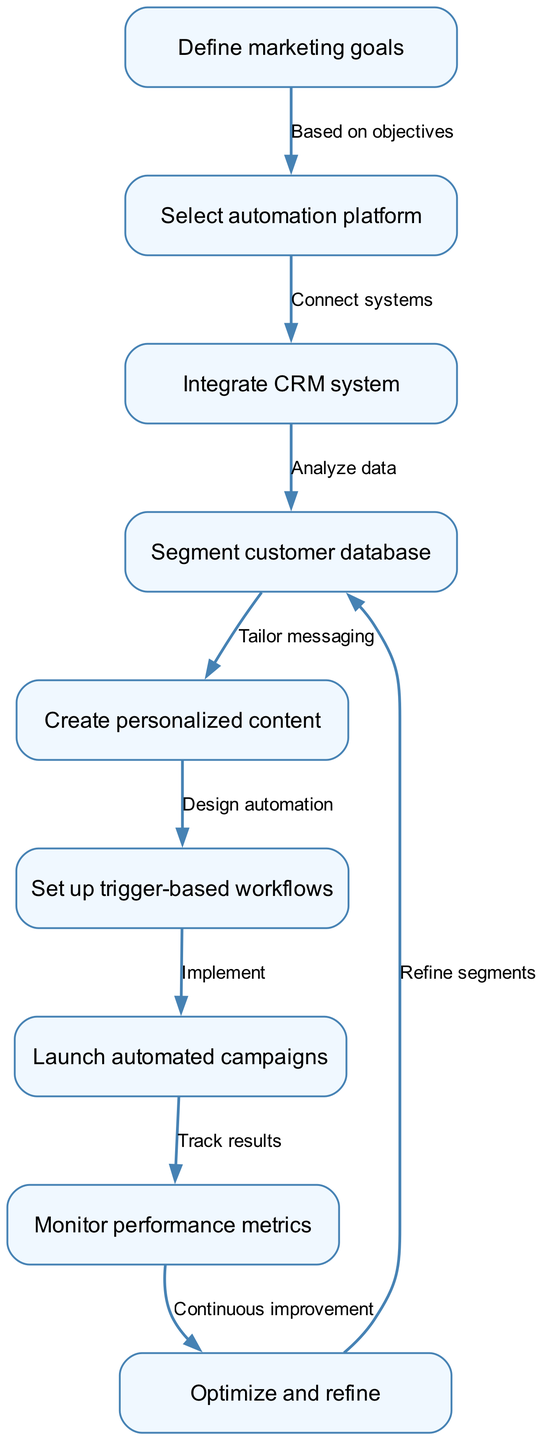What is the first step in the flow chart? The first step in the flow chart, based on the nodes, is "Define marketing goals." This is indicated as the starting point before any other actions can take place.
Answer: Define marketing goals How many steps are there in total? The total number of nodes or steps in the flow chart is nine. Counting each node listed, we have nine distinct actions to follow.
Answer: 9 What follows "Select automation platform"? After "Select automation platform," the next step is "Integrate CRM system." The diagram specifies this directional flow clearly between these two actions.
Answer: Integrate CRM system What type of content is created after segmenting the customer database? The content created after segmenting the customer database is "Create personalized content." The flow indicates that personalized content creation is dependent on customer segmentation.
Answer: Create personalized content How does the flow lead back to "Segment customer database"? After "Optimize and refine," the flow chart indicates a return to "Segment customer database." This shows that refining optimizations leads to a reevaluation of customer segments for continuous improvement.
Answer: Refine segments What action is taken after launching automated campaigns? After launching automated campaigns, the next action is "Monitor performance metrics." The direct flow from one action to the next emphasizes the importance of tracking effectiveness after launching campaigns.
Answer: Monitor performance metrics What is the relationship between "Create personalized content" and "Set up trigger-based workflows"? The relationship is that "Create personalized content" comes before "Set up trigger-based workflows." The diagram shows a sequential dependency where content creation informs the setup of workflows based on this content.
Answer: Tailor messaging What is the purpose of the "Monitor performance metrics" step? The purpose is to track results of the launched automated campaigns. This step ensures that performance is monitored for effectiveness and helps to inform further actions.
Answer: Track results What does "Optimize and refine" lead to? "Optimize and refine" leads back to "Segment customer database." This indicates a cyclical process where optimizations lead to revisiting segmentation for improved targeting.
Answer: Refine segments 